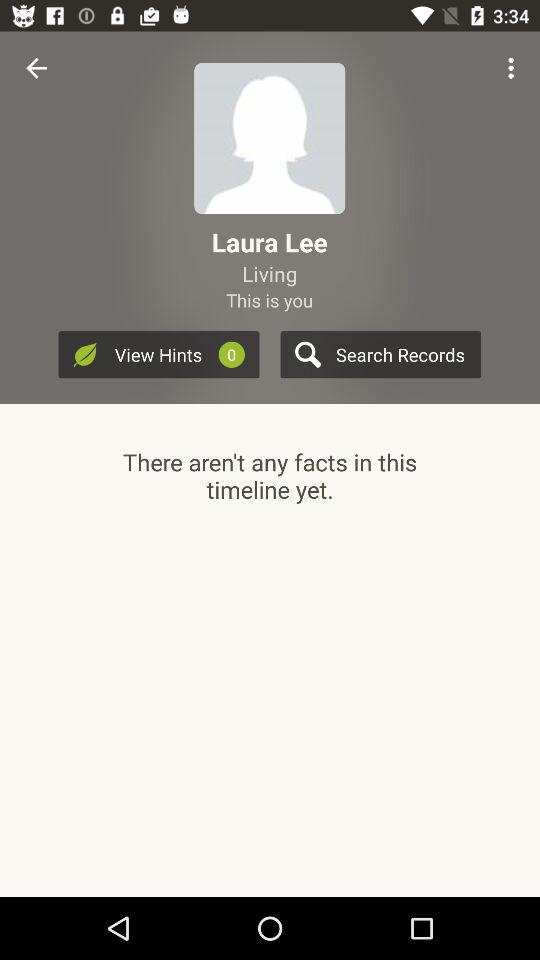Which records have been searched?
When the provided information is insufficient, respond with <no answer>. <no answer> 